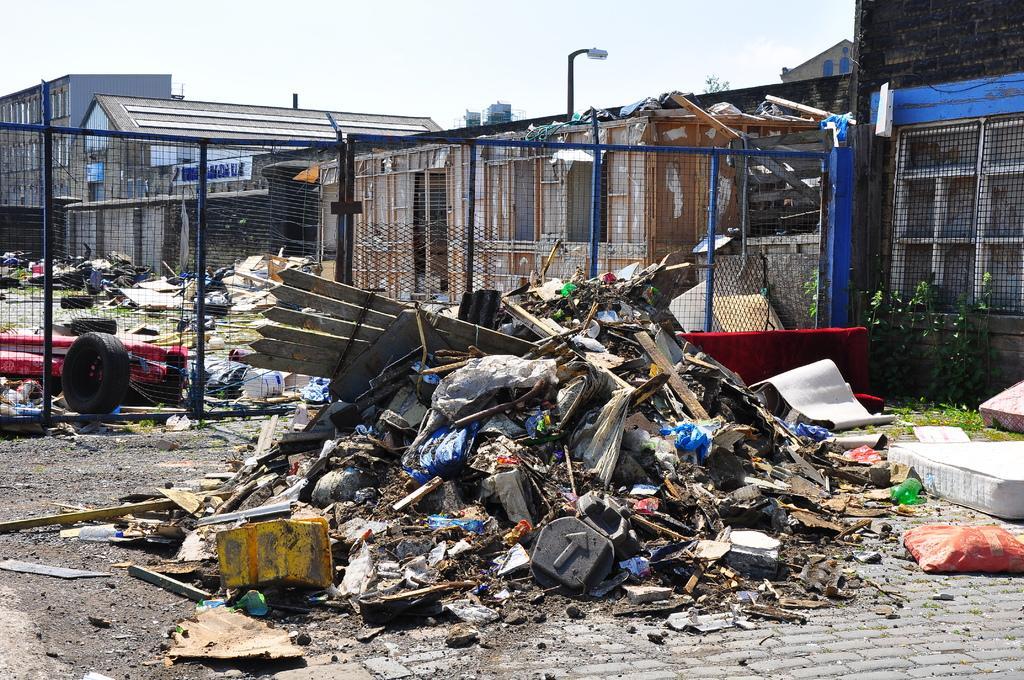Can you describe this image briefly? In the foreground, I can see wooden objects, plastic items and garbage on the road. In the background, I can see a fence, buildings, cartoon boxes, light poles, grass and the sky. This picture might be taken in a day. 